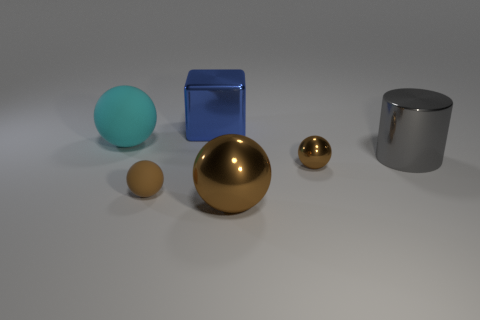Add 4 large gray metallic things. How many objects exist? 10 Subtract all brown spheres. How many were subtracted if there are1brown spheres left? 2 Subtract all brown spheres. How many spheres are left? 1 Add 1 tiny cyan matte spheres. How many tiny cyan matte spheres exist? 1 Subtract all brown balls. How many balls are left? 1 Subtract 0 red blocks. How many objects are left? 6 Subtract all cubes. How many objects are left? 5 Subtract all gray blocks. Subtract all blue cylinders. How many blocks are left? 1 Subtract all purple blocks. How many yellow cylinders are left? 0 Subtract all blue cylinders. Subtract all metallic spheres. How many objects are left? 4 